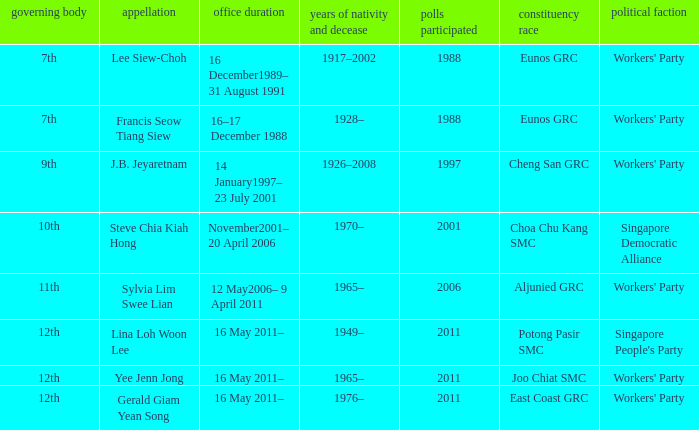During what period were parliament 11th? 12 May2006– 9 April 2011. 